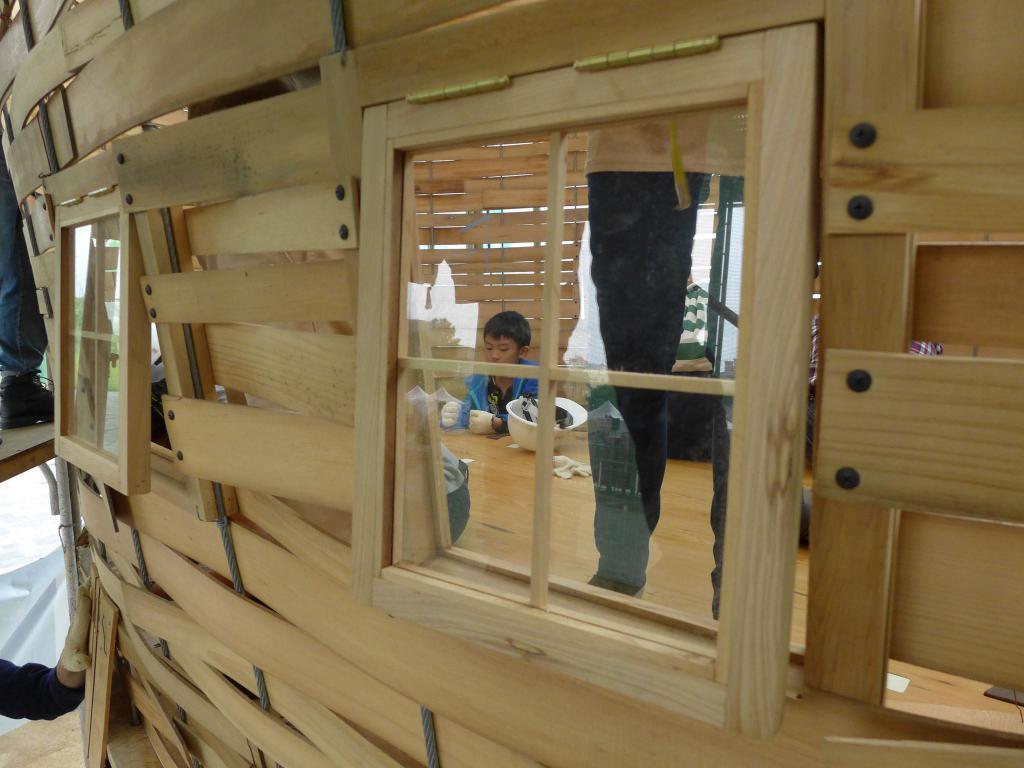Could you give a brief overview of what you see in this image? This is child, these are windows, this is wooden structure. 